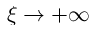Convert formula to latex. <formula><loc_0><loc_0><loc_500><loc_500>\xi \to + \infty</formula> 